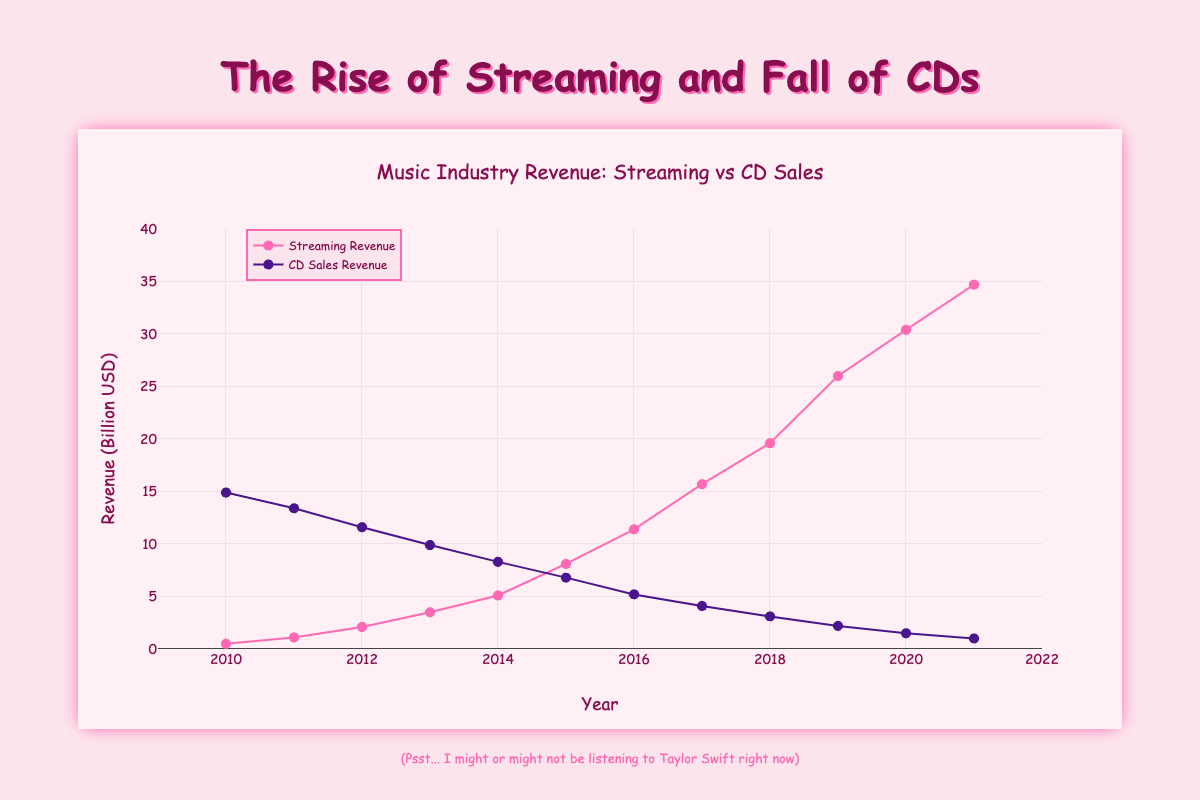what's the title of the figure? The title can be found at the top of the figure, which helps summarize the data being depicted. It reads as "Music Industry Revenue: Streaming vs CD Sales"
Answer: Music Industry Revenue: Streaming vs CD Sales What colors are used for the markers representing "Streaming Revenue" and "CD Sales Revenue"? The colors used for the markers can be identified by looking at the plot legend. "Streaming Revenue" markers are pink, and "CD Sales Revenue" markers are purple.
Answer: Pink, Purple In what year do music streaming revenues first exceed CD sales revenues? To find this, compare the trend lines for each year. The music streaming revenues first exceed CD sales revenues in 2017.
Answer: 2017 What are the revenues for music streaming and CD sales in 2021? Look at the points marked for the year 2021 on both trend lines. The revenues are 34.7 billion USD for music streaming and 1.0 billion USD for CD sales.
Answer: 34.7 billion USD, 1.0 billion USD By how much did music streaming revenue grow from 2015 to 2016? Subtract the revenue in 2015 (8.1 billion USD) from the revenue in 2016 (11.4 billion USD). The growth is 11.4 - 8.1 = 3.3 billion USD.
Answer: 3.3 billion USD Which year shows the highest increase in music streaming revenue compared to the previous year? Calculate the difference in revenue year by year and find the year with the maximum difference. The highest increase appears between 2018 (19.6 billion USD) and 2019 (26.0 billion USD), which is 26.0 - 19.6 = 6.4 billion USD.
Answer: 2019 How does CD sales revenue change over time? Observe the decreasing trend in CD sales revenue from 2010 to 2021. CD sales consistently decline each year, starting at 14.9 billion USD in 2010 and ending at 1.0 billion USD in 2021.
Answer: Decreasing Compare the trend line slopes for music streaming and CD sales. What can be inferred? The slope of the music streaming trend line is positive and steep, showing rapid growth, while the slope of the CD sales trend line is negative and steep, indicating a rapid decline.
Answer: Rapid growth in streaming, rapid decline in CD sales What is the combined revenue from both music streaming and CD sales in 2013? Add the revenues for music streaming and CD sales in 2013. The combined revenue is 3.5 (streaming) + 9.9 (CD sales) = 13.4 billion USD.
Answer: 13.4 billion USD How do music streaming and CD sales compare in 2020? For the year 2020, look at the revenues for both music streaming and CD sales. Music streaming is significantly higher at 30.4 billion USD, compared to CD sales at 1.5 billion USD.
Answer: Music streaming is significantly higher 